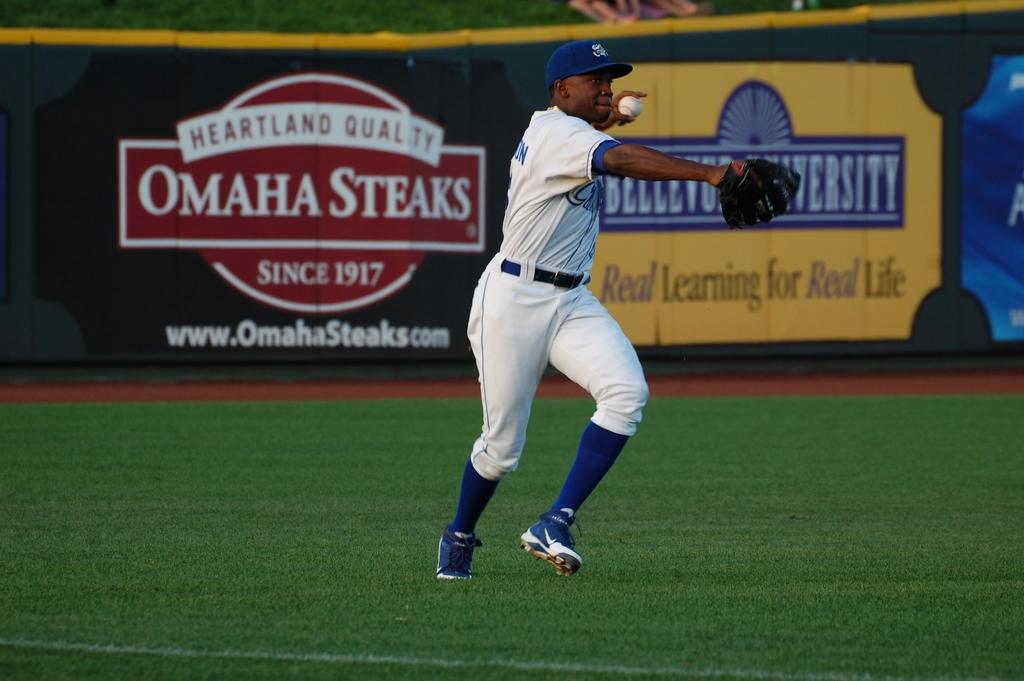What is the main subject of the image? There is a person in the image. What is the person holding in the image? The person is holding a ball. What is the person doing in the image? The person is running. What can be seen in the background of the image? There are boards visible in the background, and there is text on the boards. What type of surface is at the bottom of the image? There is grass at the bottom of the image. What is the person's income in the image? There is no information about the person's income in the image. Is there a bed visible in the image? No, there is no bed present in the image. 